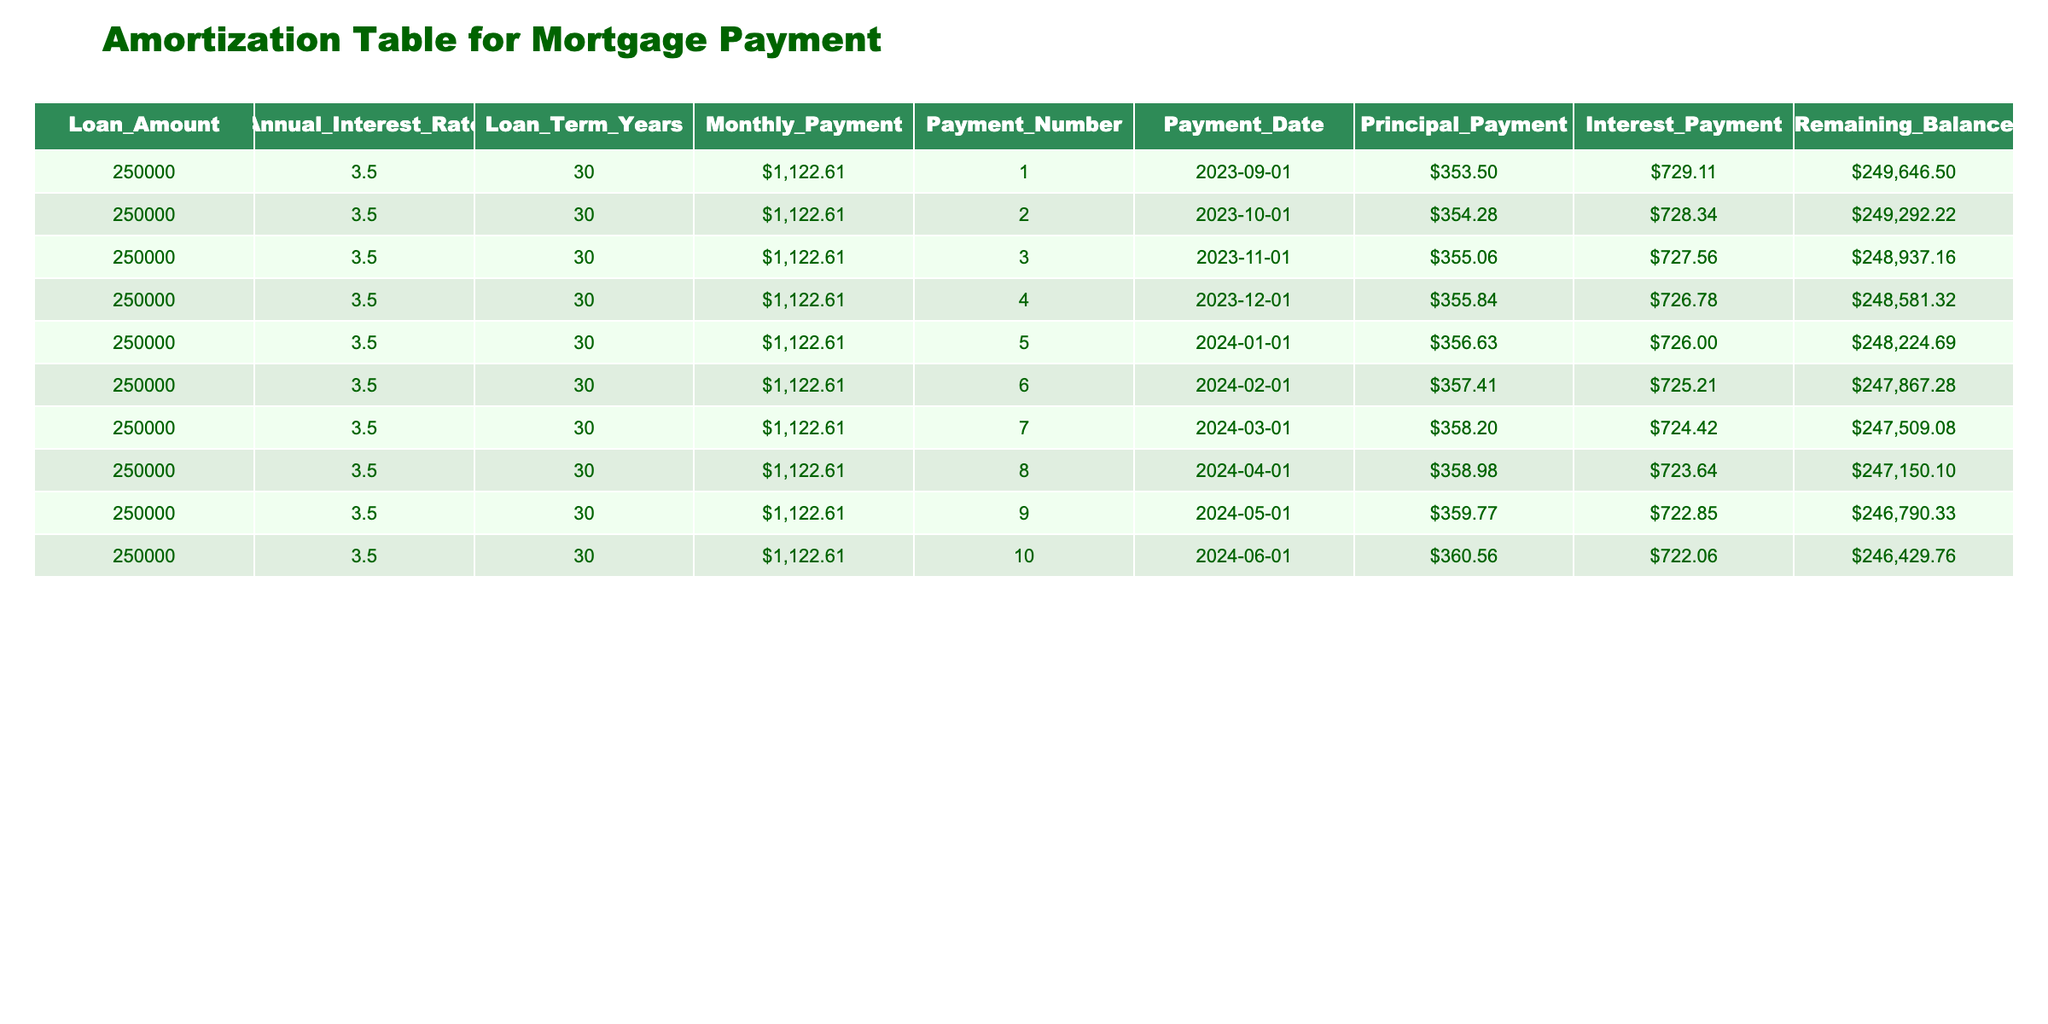What is the monthly payment amount for the loan? According to the table, the "Monthly Payment" is listed in the first row as $1,122.61. It remains the same for all payment entries as fixed payments.
Answer: $1,122.61 How much was the principal payment made in the first month? In the first row of the table, the "Principal Payment" amount is $353.50.
Answer: $353.50 What is the remaining balance after the 5th payment? The remaining balance after the 5th payment is found in the 5th row, which indicates $248,224.69.
Answer: $248,224.69 Is the interest payment less than the principal payment in the first month? The first month's principal payment is $353.50, and the interest payment is $729.11, which is greater than the principal payment. Therefore, the statement is false.
Answer: No What is the total interest paid after the first three months? The interest payments for the first three months are $729.11, $728.34, and $727.56. Adding these, we have $729.11 + $728.34 + $727.56 = $2,184.01.
Answer: $2,184.01 What is the average principal payment for the first six months? The principal payments for the first six months are $353.50, $354.28, $355.06, $355.84, $356.63, and $357.41. To find the average, sum these values: $353.50 + $354.28 + $355.06 + $355.84 + $356.63 + $357.41 = $2,132.72. Then divide by 6, which gives an average of $355.45.
Answer: $355.45 What is the maximum remaining balance shown in the table? The remaining balances for each month are $249,646.50, $249,292.22, $248,937.16, $248,581.32, $248,224.69, $247,867.28, $247,509.08, $247,150.10, $246,790.33, and $246,429.76. The maximum balance is in the first entry, which is $249,646.50.
Answer: $249,646.50 What is the difference in principal payment between the first and fourth months? The principal payments are $353.50 in the first month and $355.84 in the fourth month. To find the difference, subtract the first month's principal from the fourth month's principal: $355.84 - $353.50 = $2.34.
Answer: $2.34 What percentage of the first monthly payment is attributed to interest? The interest payment in the first month is $729.11, and the total monthly payment is $1,122.61. Therefore, the percentage of the first payment attributed to interest is (729.11 / 1122.61) * 100, which is about 64.94%.
Answer: 64.94% 